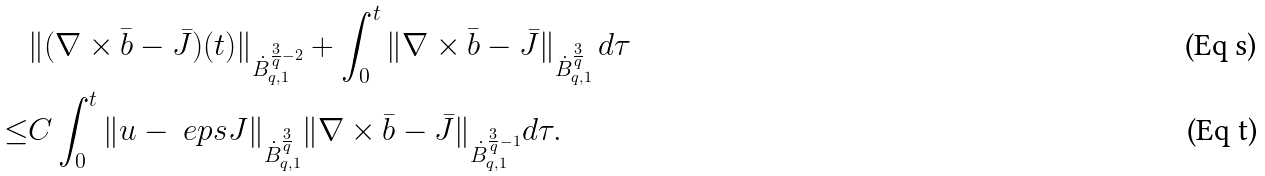<formula> <loc_0><loc_0><loc_500><loc_500>& \| ( \nabla \times \bar { b } - \bar { J } ) ( t ) \| _ { \dot { B } ^ { \frac { 3 } { q } - 2 } _ { q , 1 } } + \int _ { 0 } ^ { t } \| \nabla \times \bar { b } - \bar { J } \| _ { \dot { B } ^ { \frac { 3 } { q } } _ { q , 1 } } \, d \tau \\ \leq & C \int _ { 0 } ^ { t } \| u - \ e p s J \| _ { \dot { B } ^ { \frac { 3 } { q } } _ { q , 1 } } \| \nabla \times \bar { b } - \bar { J } \| _ { \dot { B } ^ { \frac { 3 } { q } - 1 } _ { q , 1 } } d \tau .</formula> 